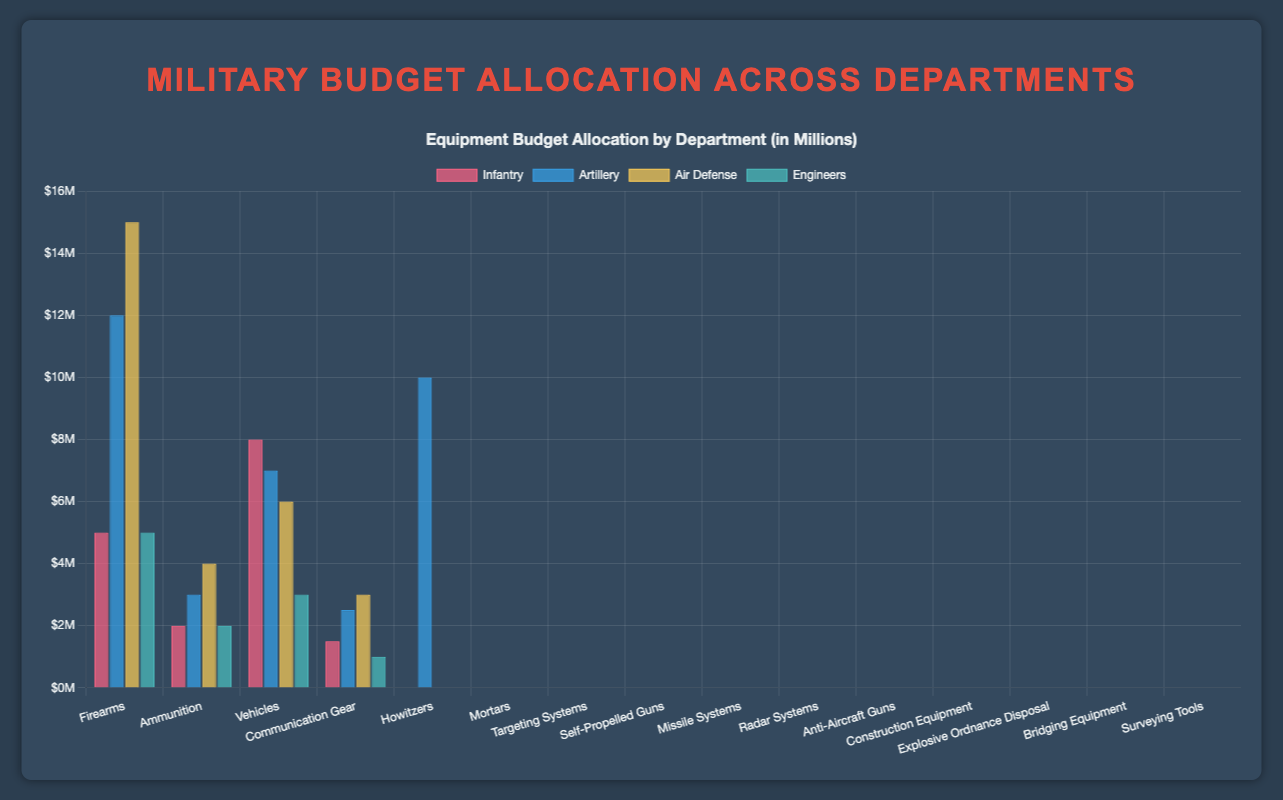Which department has the highest budget allocation for a single equipment category? The department with the highest budget allocation for a single equipment category is "Air Defense" with $15 million assigned to "Missile Systems". This can be determined by identifying the highest budget value among all equipment categories.
Answer: Air Defense How much more budget does the Infantry department spend on Vehicles compared to the Engineers department on Construction Equipment? The budget for Vehicles in the Infantry department is $8 million, and the budget for Construction Equipment in the Engineers department is $5 million. The difference is calculated as $8 million - $5 million = $3 million.
Answer: $3 million Which equipment category has the lowest budget in the Engineers department? The lowest budget equipment category in the Engineers department is "Surveying Tools" with a budget allocation of $1 million. This is determined by comparing the budgets within the Engineers department.
Answer: Surveying Tools What is the total budget for the Ammunition category across all departments? The Ammunition budget is $2 million for Infantry, $7 million for Artillery, and $3 million for Air Defense. Summing them up gives $2 million + $7 million + $3 million = $12 million.
Answer: $12 million What is the average budget allocation for equipment categories in the Artillery department? The budget allocations in the Artillery department are $12 million (Howitzers), $3 million (Mortars), $7 million (Ammunition), $2.5 million (Targeting Systems), and $10 million (Self-Propelled Guns). The average is calculated as ($12 million + $3 million + $7 million + $2.5 million + $10 million) / 5 = $34.5 million / 5 = $7.7 million.
Answer: $7.7 million Which department has the most diverse set of equipment categories, as indicated by the number of distinct categories? The Artillery department has the most diverse set of equipment categories with a total of 5: Howitzers, Mortars, Ammunition, Targeting Systems, and Self-Propelled Guns. This can be observed by counting the number of equipment categories per department.
Answer: Artillery Which equipment category has a higher budget in the Air Defense department compared to any category in the Artillery department? The "Missile Systems" category in the Air Defense department has a budget of $15 million, which is higher than any single equipment category budget in the Artillery department.
Answer: Missile Systems 